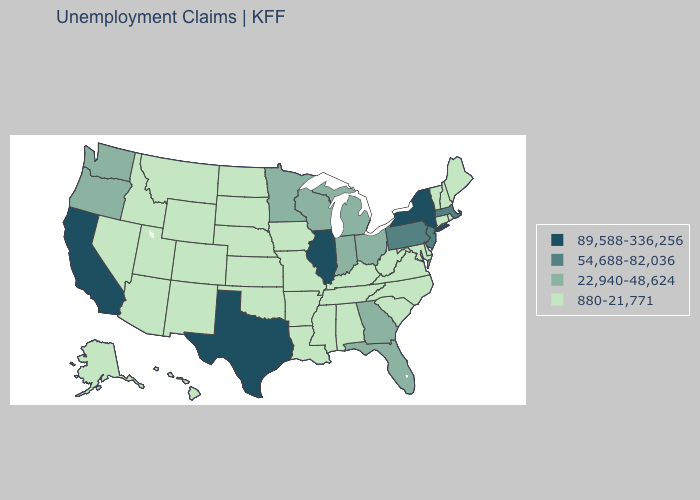Name the states that have a value in the range 54,688-82,036?
Give a very brief answer. Massachusetts, New Jersey, Pennsylvania. Which states have the highest value in the USA?
Give a very brief answer. California, Illinois, New York, Texas. What is the value of Wisconsin?
Write a very short answer. 22,940-48,624. Does Minnesota have the highest value in the MidWest?
Short answer required. No. Is the legend a continuous bar?
Be succinct. No. Name the states that have a value in the range 89,588-336,256?
Keep it brief. California, Illinois, New York, Texas. Name the states that have a value in the range 89,588-336,256?
Be succinct. California, Illinois, New York, Texas. What is the lowest value in the USA?
Quick response, please. 880-21,771. Among the states that border New Hampshire , which have the highest value?
Answer briefly. Massachusetts. Name the states that have a value in the range 89,588-336,256?
Short answer required. California, Illinois, New York, Texas. Name the states that have a value in the range 22,940-48,624?
Keep it brief. Florida, Georgia, Indiana, Michigan, Minnesota, Ohio, Oregon, Washington, Wisconsin. Does Illinois have the highest value in the MidWest?
Quick response, please. Yes. Does Michigan have the lowest value in the USA?
Be succinct. No. Does New Hampshire have a higher value than Nebraska?
Be succinct. No. What is the lowest value in the Northeast?
Give a very brief answer. 880-21,771. 